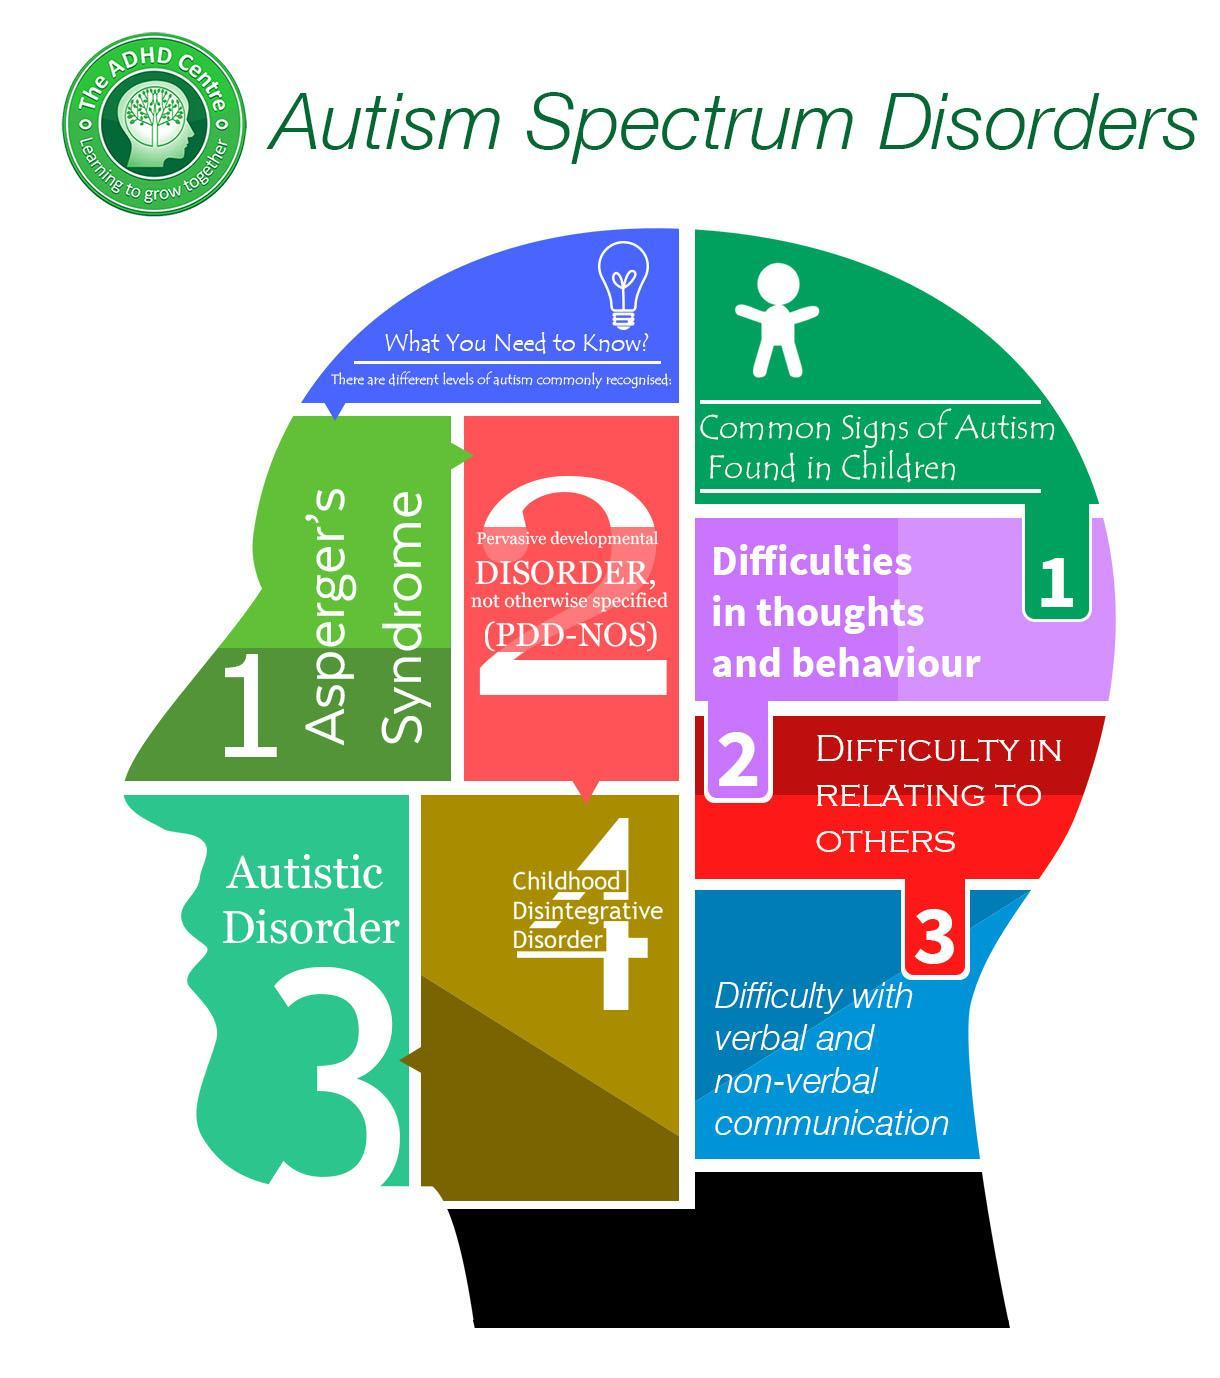What is the third sign of autism found in children?
Answer the question with a short phrase. difficulty in relating to others What is the fourth level of autism mentioned? childhood disintegrative disorder 